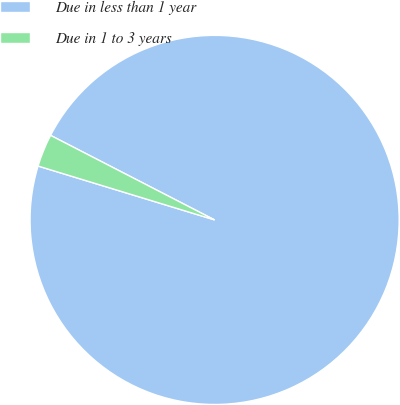<chart> <loc_0><loc_0><loc_500><loc_500><pie_chart><fcel>Due in less than 1 year<fcel>Due in 1 to 3 years<nl><fcel>97.14%<fcel>2.86%<nl></chart> 